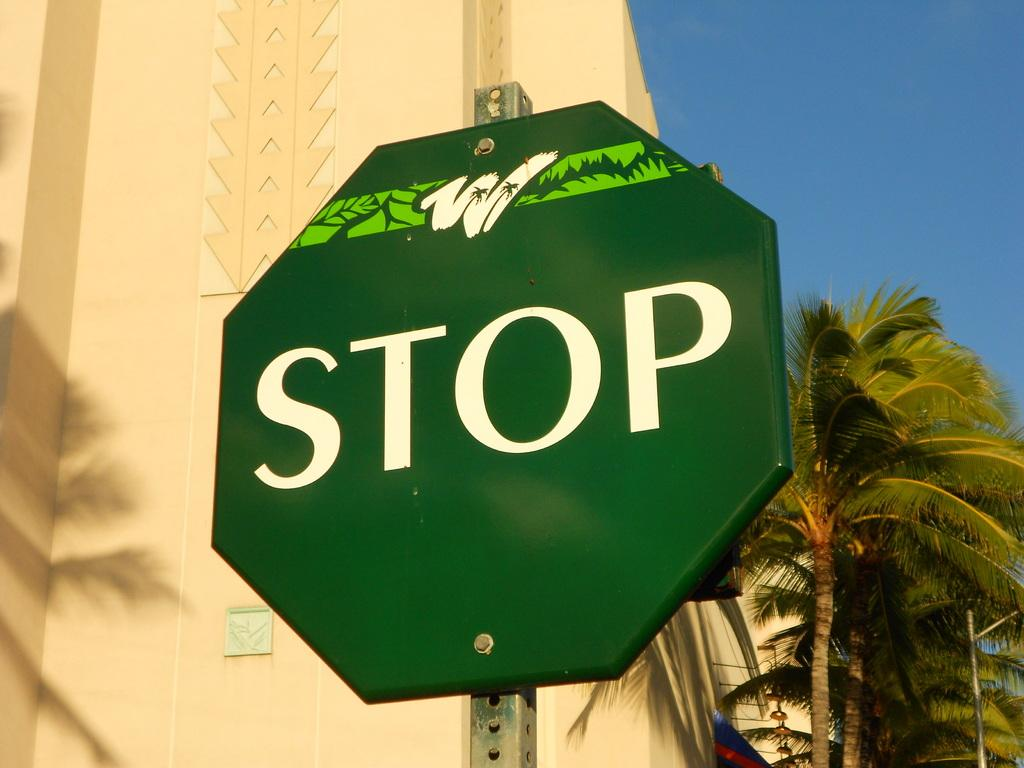<image>
Describe the image concisely. A green colored sign that says "stop" on it. 